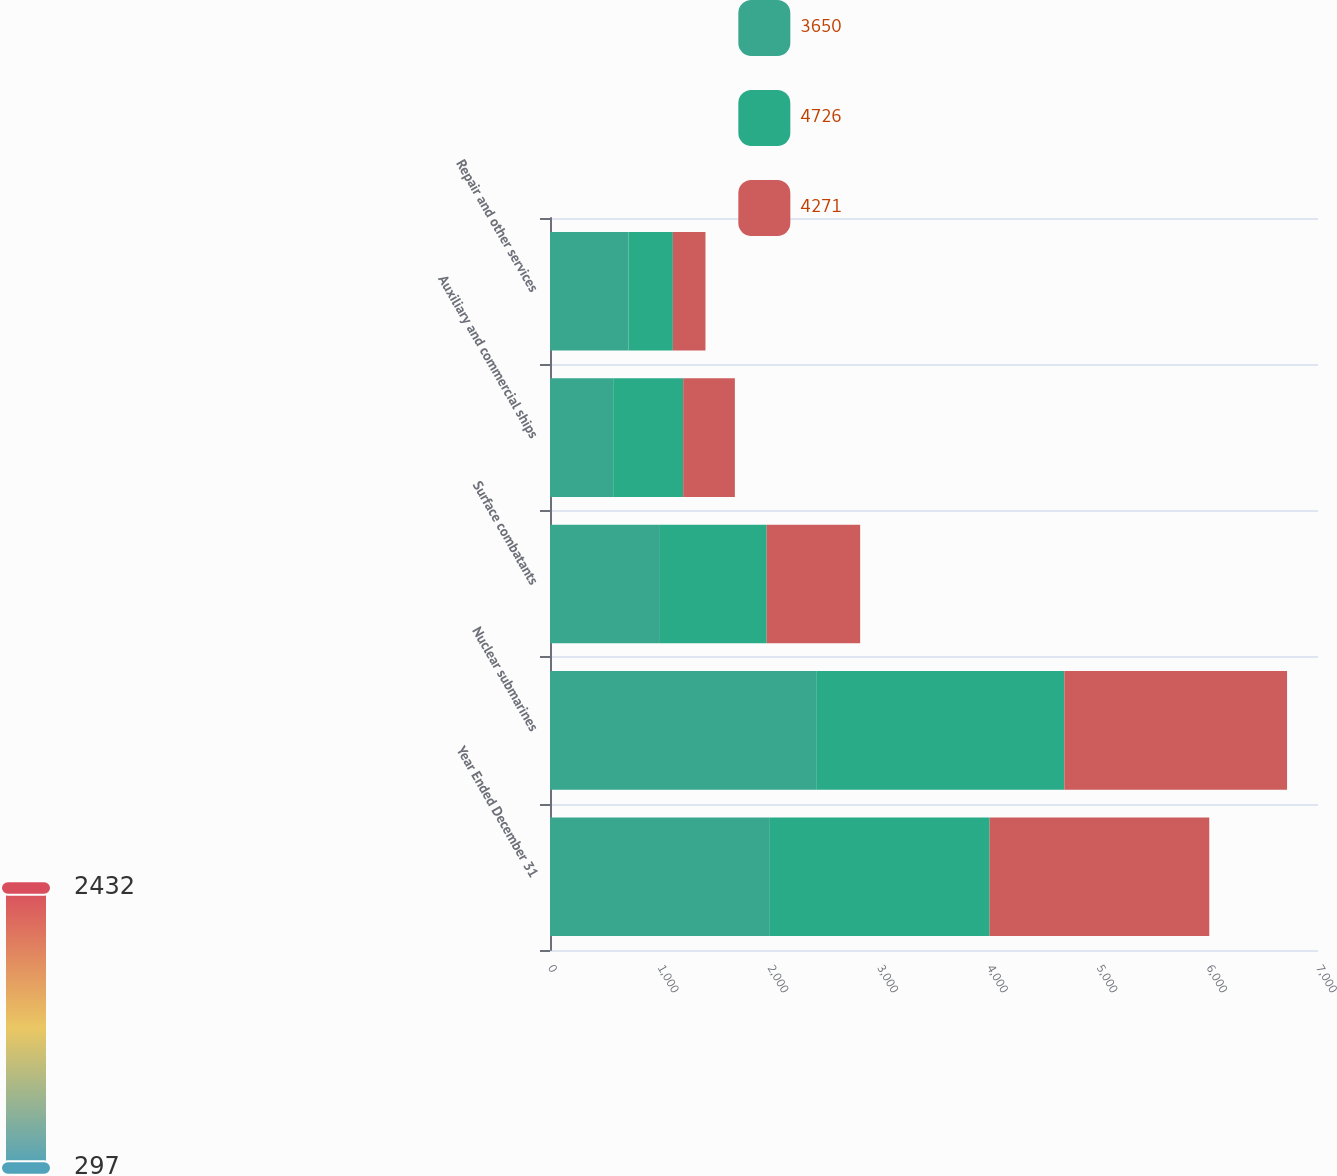Convert chart. <chart><loc_0><loc_0><loc_500><loc_500><stacked_bar_chart><ecel><fcel>Year Ended December 31<fcel>Nuclear submarines<fcel>Surface combatants<fcel>Auxiliary and commercial ships<fcel>Repair and other services<nl><fcel>3650<fcel>2004<fcel>2432<fcel>1002<fcel>576<fcel>716<nl><fcel>4726<fcel>2003<fcel>2256<fcel>973<fcel>638<fcel>404<nl><fcel>4271<fcel>2002<fcel>2030<fcel>852<fcel>471<fcel>297<nl></chart> 